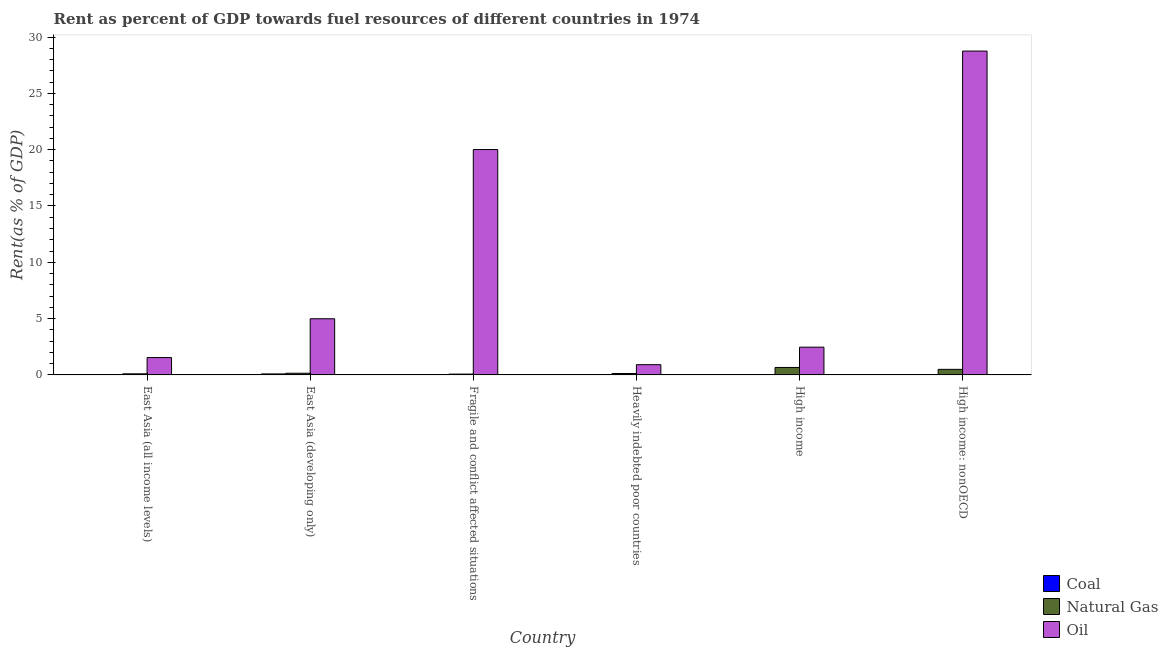How many groups of bars are there?
Ensure brevity in your answer.  6. Are the number of bars per tick equal to the number of legend labels?
Make the answer very short. Yes. How many bars are there on the 6th tick from the left?
Give a very brief answer. 3. How many bars are there on the 6th tick from the right?
Ensure brevity in your answer.  3. What is the label of the 3rd group of bars from the left?
Offer a very short reply. Fragile and conflict affected situations. In how many cases, is the number of bars for a given country not equal to the number of legend labels?
Your answer should be compact. 0. What is the rent towards coal in East Asia (developing only)?
Your answer should be compact. 0.09. Across all countries, what is the maximum rent towards oil?
Offer a very short reply. 28.76. Across all countries, what is the minimum rent towards oil?
Make the answer very short. 0.91. In which country was the rent towards natural gas maximum?
Offer a very short reply. High income. What is the total rent towards coal in the graph?
Offer a terse response. 0.12. What is the difference between the rent towards natural gas in Fragile and conflict affected situations and that in Heavily indebted poor countries?
Give a very brief answer. -0.05. What is the difference between the rent towards coal in High income: nonOECD and the rent towards oil in Fragile and conflict affected situations?
Give a very brief answer. -20.01. What is the average rent towards natural gas per country?
Offer a terse response. 0.27. What is the difference between the rent towards coal and rent towards oil in East Asia (all income levels)?
Your answer should be compact. -1.52. What is the ratio of the rent towards natural gas in East Asia (all income levels) to that in High income?
Your response must be concise. 0.15. Is the rent towards oil in East Asia (developing only) less than that in High income?
Your answer should be very brief. No. Is the difference between the rent towards coal in East Asia (all income levels) and Fragile and conflict affected situations greater than the difference between the rent towards oil in East Asia (all income levels) and Fragile and conflict affected situations?
Ensure brevity in your answer.  Yes. What is the difference between the highest and the second highest rent towards coal?
Offer a very short reply. 0.06. What is the difference between the highest and the lowest rent towards coal?
Offer a terse response. 0.09. In how many countries, is the rent towards coal greater than the average rent towards coal taken over all countries?
Provide a short and direct response. 2. What does the 1st bar from the left in Heavily indebted poor countries represents?
Ensure brevity in your answer.  Coal. What does the 3rd bar from the right in High income represents?
Offer a terse response. Coal. Is it the case that in every country, the sum of the rent towards coal and rent towards natural gas is greater than the rent towards oil?
Your answer should be very brief. No. How many bars are there?
Provide a succinct answer. 18. What is the difference between two consecutive major ticks on the Y-axis?
Make the answer very short. 5. Does the graph contain any zero values?
Your answer should be compact. No. How are the legend labels stacked?
Your response must be concise. Vertical. What is the title of the graph?
Provide a succinct answer. Rent as percent of GDP towards fuel resources of different countries in 1974. Does "Agriculture" appear as one of the legend labels in the graph?
Your response must be concise. No. What is the label or title of the X-axis?
Your response must be concise. Country. What is the label or title of the Y-axis?
Offer a very short reply. Rent(as % of GDP). What is the Rent(as % of GDP) in Coal in East Asia (all income levels)?
Your answer should be compact. 0.02. What is the Rent(as % of GDP) of Natural Gas in East Asia (all income levels)?
Your answer should be very brief. 0.1. What is the Rent(as % of GDP) in Oil in East Asia (all income levels)?
Make the answer very short. 1.54. What is the Rent(as % of GDP) of Coal in East Asia (developing only)?
Provide a short and direct response. 0.09. What is the Rent(as % of GDP) in Natural Gas in East Asia (developing only)?
Your response must be concise. 0.15. What is the Rent(as % of GDP) of Oil in East Asia (developing only)?
Give a very brief answer. 4.99. What is the Rent(as % of GDP) in Coal in Fragile and conflict affected situations?
Provide a short and direct response. 0.01. What is the Rent(as % of GDP) of Natural Gas in Fragile and conflict affected situations?
Keep it short and to the point. 0.07. What is the Rent(as % of GDP) of Oil in Fragile and conflict affected situations?
Offer a terse response. 20.01. What is the Rent(as % of GDP) in Coal in Heavily indebted poor countries?
Offer a terse response. 0. What is the Rent(as % of GDP) of Natural Gas in Heavily indebted poor countries?
Provide a short and direct response. 0.13. What is the Rent(as % of GDP) in Oil in Heavily indebted poor countries?
Your response must be concise. 0.91. What is the Rent(as % of GDP) in Coal in High income?
Your response must be concise. 0. What is the Rent(as % of GDP) in Natural Gas in High income?
Make the answer very short. 0.66. What is the Rent(as % of GDP) in Oil in High income?
Your response must be concise. 2.46. What is the Rent(as % of GDP) of Coal in High income: nonOECD?
Your answer should be compact. 0. What is the Rent(as % of GDP) of Natural Gas in High income: nonOECD?
Offer a terse response. 0.49. What is the Rent(as % of GDP) of Oil in High income: nonOECD?
Provide a short and direct response. 28.76. Across all countries, what is the maximum Rent(as % of GDP) of Coal?
Give a very brief answer. 0.09. Across all countries, what is the maximum Rent(as % of GDP) in Natural Gas?
Offer a very short reply. 0.66. Across all countries, what is the maximum Rent(as % of GDP) of Oil?
Keep it short and to the point. 28.76. Across all countries, what is the minimum Rent(as % of GDP) in Coal?
Give a very brief answer. 0. Across all countries, what is the minimum Rent(as % of GDP) of Natural Gas?
Make the answer very short. 0.07. Across all countries, what is the minimum Rent(as % of GDP) of Oil?
Make the answer very short. 0.91. What is the total Rent(as % of GDP) in Coal in the graph?
Offer a terse response. 0.12. What is the total Rent(as % of GDP) in Natural Gas in the graph?
Offer a terse response. 1.6. What is the total Rent(as % of GDP) of Oil in the graph?
Offer a very short reply. 58.67. What is the difference between the Rent(as % of GDP) of Coal in East Asia (all income levels) and that in East Asia (developing only)?
Your answer should be very brief. -0.06. What is the difference between the Rent(as % of GDP) in Natural Gas in East Asia (all income levels) and that in East Asia (developing only)?
Your answer should be very brief. -0.05. What is the difference between the Rent(as % of GDP) in Oil in East Asia (all income levels) and that in East Asia (developing only)?
Give a very brief answer. -3.44. What is the difference between the Rent(as % of GDP) of Coal in East Asia (all income levels) and that in Fragile and conflict affected situations?
Ensure brevity in your answer.  0.01. What is the difference between the Rent(as % of GDP) of Natural Gas in East Asia (all income levels) and that in Fragile and conflict affected situations?
Ensure brevity in your answer.  0.03. What is the difference between the Rent(as % of GDP) of Oil in East Asia (all income levels) and that in Fragile and conflict affected situations?
Provide a short and direct response. -18.47. What is the difference between the Rent(as % of GDP) of Coal in East Asia (all income levels) and that in Heavily indebted poor countries?
Your answer should be very brief. 0.02. What is the difference between the Rent(as % of GDP) in Natural Gas in East Asia (all income levels) and that in Heavily indebted poor countries?
Make the answer very short. -0.03. What is the difference between the Rent(as % of GDP) in Oil in East Asia (all income levels) and that in Heavily indebted poor countries?
Offer a very short reply. 0.63. What is the difference between the Rent(as % of GDP) of Coal in East Asia (all income levels) and that in High income?
Ensure brevity in your answer.  0.02. What is the difference between the Rent(as % of GDP) in Natural Gas in East Asia (all income levels) and that in High income?
Your answer should be very brief. -0.56. What is the difference between the Rent(as % of GDP) in Oil in East Asia (all income levels) and that in High income?
Your response must be concise. -0.92. What is the difference between the Rent(as % of GDP) in Coal in East Asia (all income levels) and that in High income: nonOECD?
Provide a short and direct response. 0.02. What is the difference between the Rent(as % of GDP) in Natural Gas in East Asia (all income levels) and that in High income: nonOECD?
Ensure brevity in your answer.  -0.4. What is the difference between the Rent(as % of GDP) in Oil in East Asia (all income levels) and that in High income: nonOECD?
Make the answer very short. -27.22. What is the difference between the Rent(as % of GDP) of Coal in East Asia (developing only) and that in Fragile and conflict affected situations?
Keep it short and to the point. 0.08. What is the difference between the Rent(as % of GDP) of Natural Gas in East Asia (developing only) and that in Fragile and conflict affected situations?
Your response must be concise. 0.08. What is the difference between the Rent(as % of GDP) in Oil in East Asia (developing only) and that in Fragile and conflict affected situations?
Keep it short and to the point. -15.03. What is the difference between the Rent(as % of GDP) of Coal in East Asia (developing only) and that in Heavily indebted poor countries?
Ensure brevity in your answer.  0.09. What is the difference between the Rent(as % of GDP) in Natural Gas in East Asia (developing only) and that in Heavily indebted poor countries?
Make the answer very short. 0.02. What is the difference between the Rent(as % of GDP) in Oil in East Asia (developing only) and that in Heavily indebted poor countries?
Provide a succinct answer. 4.08. What is the difference between the Rent(as % of GDP) of Coal in East Asia (developing only) and that in High income?
Your answer should be compact. 0.09. What is the difference between the Rent(as % of GDP) in Natural Gas in East Asia (developing only) and that in High income?
Your answer should be compact. -0.51. What is the difference between the Rent(as % of GDP) of Oil in East Asia (developing only) and that in High income?
Your response must be concise. 2.52. What is the difference between the Rent(as % of GDP) in Coal in East Asia (developing only) and that in High income: nonOECD?
Your answer should be compact. 0.09. What is the difference between the Rent(as % of GDP) of Natural Gas in East Asia (developing only) and that in High income: nonOECD?
Your answer should be compact. -0.35. What is the difference between the Rent(as % of GDP) in Oil in East Asia (developing only) and that in High income: nonOECD?
Offer a very short reply. -23.77. What is the difference between the Rent(as % of GDP) of Coal in Fragile and conflict affected situations and that in Heavily indebted poor countries?
Provide a succinct answer. 0.01. What is the difference between the Rent(as % of GDP) of Natural Gas in Fragile and conflict affected situations and that in Heavily indebted poor countries?
Provide a succinct answer. -0.05. What is the difference between the Rent(as % of GDP) in Oil in Fragile and conflict affected situations and that in Heavily indebted poor countries?
Keep it short and to the point. 19.1. What is the difference between the Rent(as % of GDP) in Coal in Fragile and conflict affected situations and that in High income?
Provide a short and direct response. 0.01. What is the difference between the Rent(as % of GDP) of Natural Gas in Fragile and conflict affected situations and that in High income?
Your response must be concise. -0.59. What is the difference between the Rent(as % of GDP) in Oil in Fragile and conflict affected situations and that in High income?
Provide a succinct answer. 17.55. What is the difference between the Rent(as % of GDP) in Coal in Fragile and conflict affected situations and that in High income: nonOECD?
Provide a short and direct response. 0.01. What is the difference between the Rent(as % of GDP) of Natural Gas in Fragile and conflict affected situations and that in High income: nonOECD?
Offer a very short reply. -0.42. What is the difference between the Rent(as % of GDP) of Oil in Fragile and conflict affected situations and that in High income: nonOECD?
Make the answer very short. -8.74. What is the difference between the Rent(as % of GDP) of Coal in Heavily indebted poor countries and that in High income?
Provide a short and direct response. 0. What is the difference between the Rent(as % of GDP) of Natural Gas in Heavily indebted poor countries and that in High income?
Keep it short and to the point. -0.54. What is the difference between the Rent(as % of GDP) in Oil in Heavily indebted poor countries and that in High income?
Provide a short and direct response. -1.55. What is the difference between the Rent(as % of GDP) in Coal in Heavily indebted poor countries and that in High income: nonOECD?
Give a very brief answer. 0. What is the difference between the Rent(as % of GDP) in Natural Gas in Heavily indebted poor countries and that in High income: nonOECD?
Give a very brief answer. -0.37. What is the difference between the Rent(as % of GDP) in Oil in Heavily indebted poor countries and that in High income: nonOECD?
Offer a very short reply. -27.85. What is the difference between the Rent(as % of GDP) in Coal in High income and that in High income: nonOECD?
Provide a succinct answer. -0. What is the difference between the Rent(as % of GDP) of Natural Gas in High income and that in High income: nonOECD?
Your answer should be compact. 0.17. What is the difference between the Rent(as % of GDP) of Oil in High income and that in High income: nonOECD?
Make the answer very short. -26.29. What is the difference between the Rent(as % of GDP) in Coal in East Asia (all income levels) and the Rent(as % of GDP) in Natural Gas in East Asia (developing only)?
Offer a very short reply. -0.12. What is the difference between the Rent(as % of GDP) in Coal in East Asia (all income levels) and the Rent(as % of GDP) in Oil in East Asia (developing only)?
Offer a very short reply. -4.96. What is the difference between the Rent(as % of GDP) of Natural Gas in East Asia (all income levels) and the Rent(as % of GDP) of Oil in East Asia (developing only)?
Your answer should be very brief. -4.89. What is the difference between the Rent(as % of GDP) in Coal in East Asia (all income levels) and the Rent(as % of GDP) in Natural Gas in Fragile and conflict affected situations?
Your response must be concise. -0.05. What is the difference between the Rent(as % of GDP) in Coal in East Asia (all income levels) and the Rent(as % of GDP) in Oil in Fragile and conflict affected situations?
Provide a short and direct response. -19.99. What is the difference between the Rent(as % of GDP) of Natural Gas in East Asia (all income levels) and the Rent(as % of GDP) of Oil in Fragile and conflict affected situations?
Provide a short and direct response. -19.92. What is the difference between the Rent(as % of GDP) in Coal in East Asia (all income levels) and the Rent(as % of GDP) in Natural Gas in Heavily indebted poor countries?
Your answer should be compact. -0.1. What is the difference between the Rent(as % of GDP) in Coal in East Asia (all income levels) and the Rent(as % of GDP) in Oil in Heavily indebted poor countries?
Offer a very short reply. -0.89. What is the difference between the Rent(as % of GDP) of Natural Gas in East Asia (all income levels) and the Rent(as % of GDP) of Oil in Heavily indebted poor countries?
Provide a succinct answer. -0.81. What is the difference between the Rent(as % of GDP) of Coal in East Asia (all income levels) and the Rent(as % of GDP) of Natural Gas in High income?
Your answer should be very brief. -0.64. What is the difference between the Rent(as % of GDP) of Coal in East Asia (all income levels) and the Rent(as % of GDP) of Oil in High income?
Your answer should be very brief. -2.44. What is the difference between the Rent(as % of GDP) of Natural Gas in East Asia (all income levels) and the Rent(as % of GDP) of Oil in High income?
Offer a terse response. -2.37. What is the difference between the Rent(as % of GDP) of Coal in East Asia (all income levels) and the Rent(as % of GDP) of Natural Gas in High income: nonOECD?
Offer a terse response. -0.47. What is the difference between the Rent(as % of GDP) in Coal in East Asia (all income levels) and the Rent(as % of GDP) in Oil in High income: nonOECD?
Make the answer very short. -28.73. What is the difference between the Rent(as % of GDP) in Natural Gas in East Asia (all income levels) and the Rent(as % of GDP) in Oil in High income: nonOECD?
Give a very brief answer. -28.66. What is the difference between the Rent(as % of GDP) of Coal in East Asia (developing only) and the Rent(as % of GDP) of Natural Gas in Fragile and conflict affected situations?
Your answer should be very brief. 0.02. What is the difference between the Rent(as % of GDP) in Coal in East Asia (developing only) and the Rent(as % of GDP) in Oil in Fragile and conflict affected situations?
Give a very brief answer. -19.93. What is the difference between the Rent(as % of GDP) of Natural Gas in East Asia (developing only) and the Rent(as % of GDP) of Oil in Fragile and conflict affected situations?
Offer a terse response. -19.87. What is the difference between the Rent(as % of GDP) in Coal in East Asia (developing only) and the Rent(as % of GDP) in Natural Gas in Heavily indebted poor countries?
Keep it short and to the point. -0.04. What is the difference between the Rent(as % of GDP) in Coal in East Asia (developing only) and the Rent(as % of GDP) in Oil in Heavily indebted poor countries?
Offer a very short reply. -0.82. What is the difference between the Rent(as % of GDP) in Natural Gas in East Asia (developing only) and the Rent(as % of GDP) in Oil in Heavily indebted poor countries?
Provide a short and direct response. -0.76. What is the difference between the Rent(as % of GDP) in Coal in East Asia (developing only) and the Rent(as % of GDP) in Natural Gas in High income?
Offer a very short reply. -0.57. What is the difference between the Rent(as % of GDP) in Coal in East Asia (developing only) and the Rent(as % of GDP) in Oil in High income?
Offer a terse response. -2.38. What is the difference between the Rent(as % of GDP) in Natural Gas in East Asia (developing only) and the Rent(as % of GDP) in Oil in High income?
Your answer should be very brief. -2.32. What is the difference between the Rent(as % of GDP) in Coal in East Asia (developing only) and the Rent(as % of GDP) in Natural Gas in High income: nonOECD?
Provide a short and direct response. -0.41. What is the difference between the Rent(as % of GDP) of Coal in East Asia (developing only) and the Rent(as % of GDP) of Oil in High income: nonOECD?
Keep it short and to the point. -28.67. What is the difference between the Rent(as % of GDP) in Natural Gas in East Asia (developing only) and the Rent(as % of GDP) in Oil in High income: nonOECD?
Your response must be concise. -28.61. What is the difference between the Rent(as % of GDP) in Coal in Fragile and conflict affected situations and the Rent(as % of GDP) in Natural Gas in Heavily indebted poor countries?
Your response must be concise. -0.12. What is the difference between the Rent(as % of GDP) of Coal in Fragile and conflict affected situations and the Rent(as % of GDP) of Oil in Heavily indebted poor countries?
Provide a short and direct response. -0.9. What is the difference between the Rent(as % of GDP) of Natural Gas in Fragile and conflict affected situations and the Rent(as % of GDP) of Oil in Heavily indebted poor countries?
Your answer should be very brief. -0.84. What is the difference between the Rent(as % of GDP) in Coal in Fragile and conflict affected situations and the Rent(as % of GDP) in Natural Gas in High income?
Ensure brevity in your answer.  -0.65. What is the difference between the Rent(as % of GDP) of Coal in Fragile and conflict affected situations and the Rent(as % of GDP) of Oil in High income?
Offer a very short reply. -2.46. What is the difference between the Rent(as % of GDP) in Natural Gas in Fragile and conflict affected situations and the Rent(as % of GDP) in Oil in High income?
Provide a succinct answer. -2.39. What is the difference between the Rent(as % of GDP) of Coal in Fragile and conflict affected situations and the Rent(as % of GDP) of Natural Gas in High income: nonOECD?
Provide a succinct answer. -0.49. What is the difference between the Rent(as % of GDP) of Coal in Fragile and conflict affected situations and the Rent(as % of GDP) of Oil in High income: nonOECD?
Your answer should be very brief. -28.75. What is the difference between the Rent(as % of GDP) of Natural Gas in Fragile and conflict affected situations and the Rent(as % of GDP) of Oil in High income: nonOECD?
Offer a very short reply. -28.69. What is the difference between the Rent(as % of GDP) of Coal in Heavily indebted poor countries and the Rent(as % of GDP) of Natural Gas in High income?
Offer a terse response. -0.66. What is the difference between the Rent(as % of GDP) of Coal in Heavily indebted poor countries and the Rent(as % of GDP) of Oil in High income?
Keep it short and to the point. -2.46. What is the difference between the Rent(as % of GDP) of Natural Gas in Heavily indebted poor countries and the Rent(as % of GDP) of Oil in High income?
Give a very brief answer. -2.34. What is the difference between the Rent(as % of GDP) of Coal in Heavily indebted poor countries and the Rent(as % of GDP) of Natural Gas in High income: nonOECD?
Your response must be concise. -0.49. What is the difference between the Rent(as % of GDP) in Coal in Heavily indebted poor countries and the Rent(as % of GDP) in Oil in High income: nonOECD?
Give a very brief answer. -28.75. What is the difference between the Rent(as % of GDP) in Natural Gas in Heavily indebted poor countries and the Rent(as % of GDP) in Oil in High income: nonOECD?
Ensure brevity in your answer.  -28.63. What is the difference between the Rent(as % of GDP) in Coal in High income and the Rent(as % of GDP) in Natural Gas in High income: nonOECD?
Offer a terse response. -0.49. What is the difference between the Rent(as % of GDP) in Coal in High income and the Rent(as % of GDP) in Oil in High income: nonOECD?
Your answer should be compact. -28.76. What is the difference between the Rent(as % of GDP) of Natural Gas in High income and the Rent(as % of GDP) of Oil in High income: nonOECD?
Give a very brief answer. -28.1. What is the average Rent(as % of GDP) of Coal per country?
Ensure brevity in your answer.  0.02. What is the average Rent(as % of GDP) of Natural Gas per country?
Provide a succinct answer. 0.27. What is the average Rent(as % of GDP) in Oil per country?
Make the answer very short. 9.78. What is the difference between the Rent(as % of GDP) in Coal and Rent(as % of GDP) in Natural Gas in East Asia (all income levels)?
Your response must be concise. -0.07. What is the difference between the Rent(as % of GDP) of Coal and Rent(as % of GDP) of Oil in East Asia (all income levels)?
Your response must be concise. -1.52. What is the difference between the Rent(as % of GDP) in Natural Gas and Rent(as % of GDP) in Oil in East Asia (all income levels)?
Make the answer very short. -1.44. What is the difference between the Rent(as % of GDP) in Coal and Rent(as % of GDP) in Natural Gas in East Asia (developing only)?
Your response must be concise. -0.06. What is the difference between the Rent(as % of GDP) of Coal and Rent(as % of GDP) of Oil in East Asia (developing only)?
Give a very brief answer. -4.9. What is the difference between the Rent(as % of GDP) of Natural Gas and Rent(as % of GDP) of Oil in East Asia (developing only)?
Provide a succinct answer. -4.84. What is the difference between the Rent(as % of GDP) in Coal and Rent(as % of GDP) in Natural Gas in Fragile and conflict affected situations?
Your response must be concise. -0.06. What is the difference between the Rent(as % of GDP) in Coal and Rent(as % of GDP) in Oil in Fragile and conflict affected situations?
Make the answer very short. -20. What is the difference between the Rent(as % of GDP) in Natural Gas and Rent(as % of GDP) in Oil in Fragile and conflict affected situations?
Provide a succinct answer. -19.94. What is the difference between the Rent(as % of GDP) in Coal and Rent(as % of GDP) in Natural Gas in Heavily indebted poor countries?
Your answer should be compact. -0.12. What is the difference between the Rent(as % of GDP) in Coal and Rent(as % of GDP) in Oil in Heavily indebted poor countries?
Your response must be concise. -0.91. What is the difference between the Rent(as % of GDP) in Natural Gas and Rent(as % of GDP) in Oil in Heavily indebted poor countries?
Your response must be concise. -0.78. What is the difference between the Rent(as % of GDP) in Coal and Rent(as % of GDP) in Natural Gas in High income?
Give a very brief answer. -0.66. What is the difference between the Rent(as % of GDP) of Coal and Rent(as % of GDP) of Oil in High income?
Keep it short and to the point. -2.46. What is the difference between the Rent(as % of GDP) in Natural Gas and Rent(as % of GDP) in Oil in High income?
Make the answer very short. -1.8. What is the difference between the Rent(as % of GDP) of Coal and Rent(as % of GDP) of Natural Gas in High income: nonOECD?
Ensure brevity in your answer.  -0.49. What is the difference between the Rent(as % of GDP) in Coal and Rent(as % of GDP) in Oil in High income: nonOECD?
Ensure brevity in your answer.  -28.76. What is the difference between the Rent(as % of GDP) of Natural Gas and Rent(as % of GDP) of Oil in High income: nonOECD?
Offer a very short reply. -28.26. What is the ratio of the Rent(as % of GDP) in Coal in East Asia (all income levels) to that in East Asia (developing only)?
Offer a very short reply. 0.26. What is the ratio of the Rent(as % of GDP) of Natural Gas in East Asia (all income levels) to that in East Asia (developing only)?
Provide a short and direct response. 0.66. What is the ratio of the Rent(as % of GDP) in Oil in East Asia (all income levels) to that in East Asia (developing only)?
Make the answer very short. 0.31. What is the ratio of the Rent(as % of GDP) in Coal in East Asia (all income levels) to that in Fragile and conflict affected situations?
Your answer should be very brief. 2.75. What is the ratio of the Rent(as % of GDP) of Natural Gas in East Asia (all income levels) to that in Fragile and conflict affected situations?
Provide a short and direct response. 1.35. What is the ratio of the Rent(as % of GDP) in Oil in East Asia (all income levels) to that in Fragile and conflict affected situations?
Give a very brief answer. 0.08. What is the ratio of the Rent(as % of GDP) of Coal in East Asia (all income levels) to that in Heavily indebted poor countries?
Offer a terse response. 10.43. What is the ratio of the Rent(as % of GDP) in Natural Gas in East Asia (all income levels) to that in Heavily indebted poor countries?
Ensure brevity in your answer.  0.77. What is the ratio of the Rent(as % of GDP) in Oil in East Asia (all income levels) to that in Heavily indebted poor countries?
Give a very brief answer. 1.7. What is the ratio of the Rent(as % of GDP) of Coal in East Asia (all income levels) to that in High income?
Offer a terse response. 114.59. What is the ratio of the Rent(as % of GDP) in Natural Gas in East Asia (all income levels) to that in High income?
Your answer should be very brief. 0.15. What is the ratio of the Rent(as % of GDP) in Oil in East Asia (all income levels) to that in High income?
Your answer should be very brief. 0.63. What is the ratio of the Rent(as % of GDP) of Coal in East Asia (all income levels) to that in High income: nonOECD?
Keep it short and to the point. 29.51. What is the ratio of the Rent(as % of GDP) of Natural Gas in East Asia (all income levels) to that in High income: nonOECD?
Give a very brief answer. 0.2. What is the ratio of the Rent(as % of GDP) in Oil in East Asia (all income levels) to that in High income: nonOECD?
Your answer should be compact. 0.05. What is the ratio of the Rent(as % of GDP) of Coal in East Asia (developing only) to that in Fragile and conflict affected situations?
Offer a very short reply. 10.5. What is the ratio of the Rent(as % of GDP) of Natural Gas in East Asia (developing only) to that in Fragile and conflict affected situations?
Provide a short and direct response. 2.06. What is the ratio of the Rent(as % of GDP) in Oil in East Asia (developing only) to that in Fragile and conflict affected situations?
Give a very brief answer. 0.25. What is the ratio of the Rent(as % of GDP) of Coal in East Asia (developing only) to that in Heavily indebted poor countries?
Offer a very short reply. 39.82. What is the ratio of the Rent(as % of GDP) in Natural Gas in East Asia (developing only) to that in Heavily indebted poor countries?
Your response must be concise. 1.18. What is the ratio of the Rent(as % of GDP) of Oil in East Asia (developing only) to that in Heavily indebted poor countries?
Give a very brief answer. 5.49. What is the ratio of the Rent(as % of GDP) in Coal in East Asia (developing only) to that in High income?
Your answer should be compact. 437.72. What is the ratio of the Rent(as % of GDP) in Natural Gas in East Asia (developing only) to that in High income?
Provide a succinct answer. 0.22. What is the ratio of the Rent(as % of GDP) of Oil in East Asia (developing only) to that in High income?
Ensure brevity in your answer.  2.02. What is the ratio of the Rent(as % of GDP) in Coal in East Asia (developing only) to that in High income: nonOECD?
Offer a terse response. 112.72. What is the ratio of the Rent(as % of GDP) in Natural Gas in East Asia (developing only) to that in High income: nonOECD?
Give a very brief answer. 0.3. What is the ratio of the Rent(as % of GDP) of Oil in East Asia (developing only) to that in High income: nonOECD?
Make the answer very short. 0.17. What is the ratio of the Rent(as % of GDP) in Coal in Fragile and conflict affected situations to that in Heavily indebted poor countries?
Ensure brevity in your answer.  3.79. What is the ratio of the Rent(as % of GDP) of Natural Gas in Fragile and conflict affected situations to that in Heavily indebted poor countries?
Offer a terse response. 0.57. What is the ratio of the Rent(as % of GDP) in Oil in Fragile and conflict affected situations to that in Heavily indebted poor countries?
Provide a short and direct response. 22.02. What is the ratio of the Rent(as % of GDP) in Coal in Fragile and conflict affected situations to that in High income?
Provide a succinct answer. 41.67. What is the ratio of the Rent(as % of GDP) of Natural Gas in Fragile and conflict affected situations to that in High income?
Your response must be concise. 0.11. What is the ratio of the Rent(as % of GDP) in Oil in Fragile and conflict affected situations to that in High income?
Provide a succinct answer. 8.12. What is the ratio of the Rent(as % of GDP) of Coal in Fragile and conflict affected situations to that in High income: nonOECD?
Keep it short and to the point. 10.73. What is the ratio of the Rent(as % of GDP) of Natural Gas in Fragile and conflict affected situations to that in High income: nonOECD?
Provide a succinct answer. 0.14. What is the ratio of the Rent(as % of GDP) in Oil in Fragile and conflict affected situations to that in High income: nonOECD?
Your answer should be very brief. 0.7. What is the ratio of the Rent(as % of GDP) of Coal in Heavily indebted poor countries to that in High income?
Offer a terse response. 10.99. What is the ratio of the Rent(as % of GDP) in Natural Gas in Heavily indebted poor countries to that in High income?
Your answer should be compact. 0.19. What is the ratio of the Rent(as % of GDP) in Oil in Heavily indebted poor countries to that in High income?
Keep it short and to the point. 0.37. What is the ratio of the Rent(as % of GDP) in Coal in Heavily indebted poor countries to that in High income: nonOECD?
Give a very brief answer. 2.83. What is the ratio of the Rent(as % of GDP) of Natural Gas in Heavily indebted poor countries to that in High income: nonOECD?
Make the answer very short. 0.25. What is the ratio of the Rent(as % of GDP) in Oil in Heavily indebted poor countries to that in High income: nonOECD?
Provide a succinct answer. 0.03. What is the ratio of the Rent(as % of GDP) in Coal in High income to that in High income: nonOECD?
Your answer should be compact. 0.26. What is the ratio of the Rent(as % of GDP) of Natural Gas in High income to that in High income: nonOECD?
Provide a short and direct response. 1.34. What is the ratio of the Rent(as % of GDP) of Oil in High income to that in High income: nonOECD?
Ensure brevity in your answer.  0.09. What is the difference between the highest and the second highest Rent(as % of GDP) in Coal?
Make the answer very short. 0.06. What is the difference between the highest and the second highest Rent(as % of GDP) of Natural Gas?
Your answer should be very brief. 0.17. What is the difference between the highest and the second highest Rent(as % of GDP) of Oil?
Provide a succinct answer. 8.74. What is the difference between the highest and the lowest Rent(as % of GDP) of Coal?
Provide a succinct answer. 0.09. What is the difference between the highest and the lowest Rent(as % of GDP) in Natural Gas?
Ensure brevity in your answer.  0.59. What is the difference between the highest and the lowest Rent(as % of GDP) of Oil?
Offer a very short reply. 27.85. 